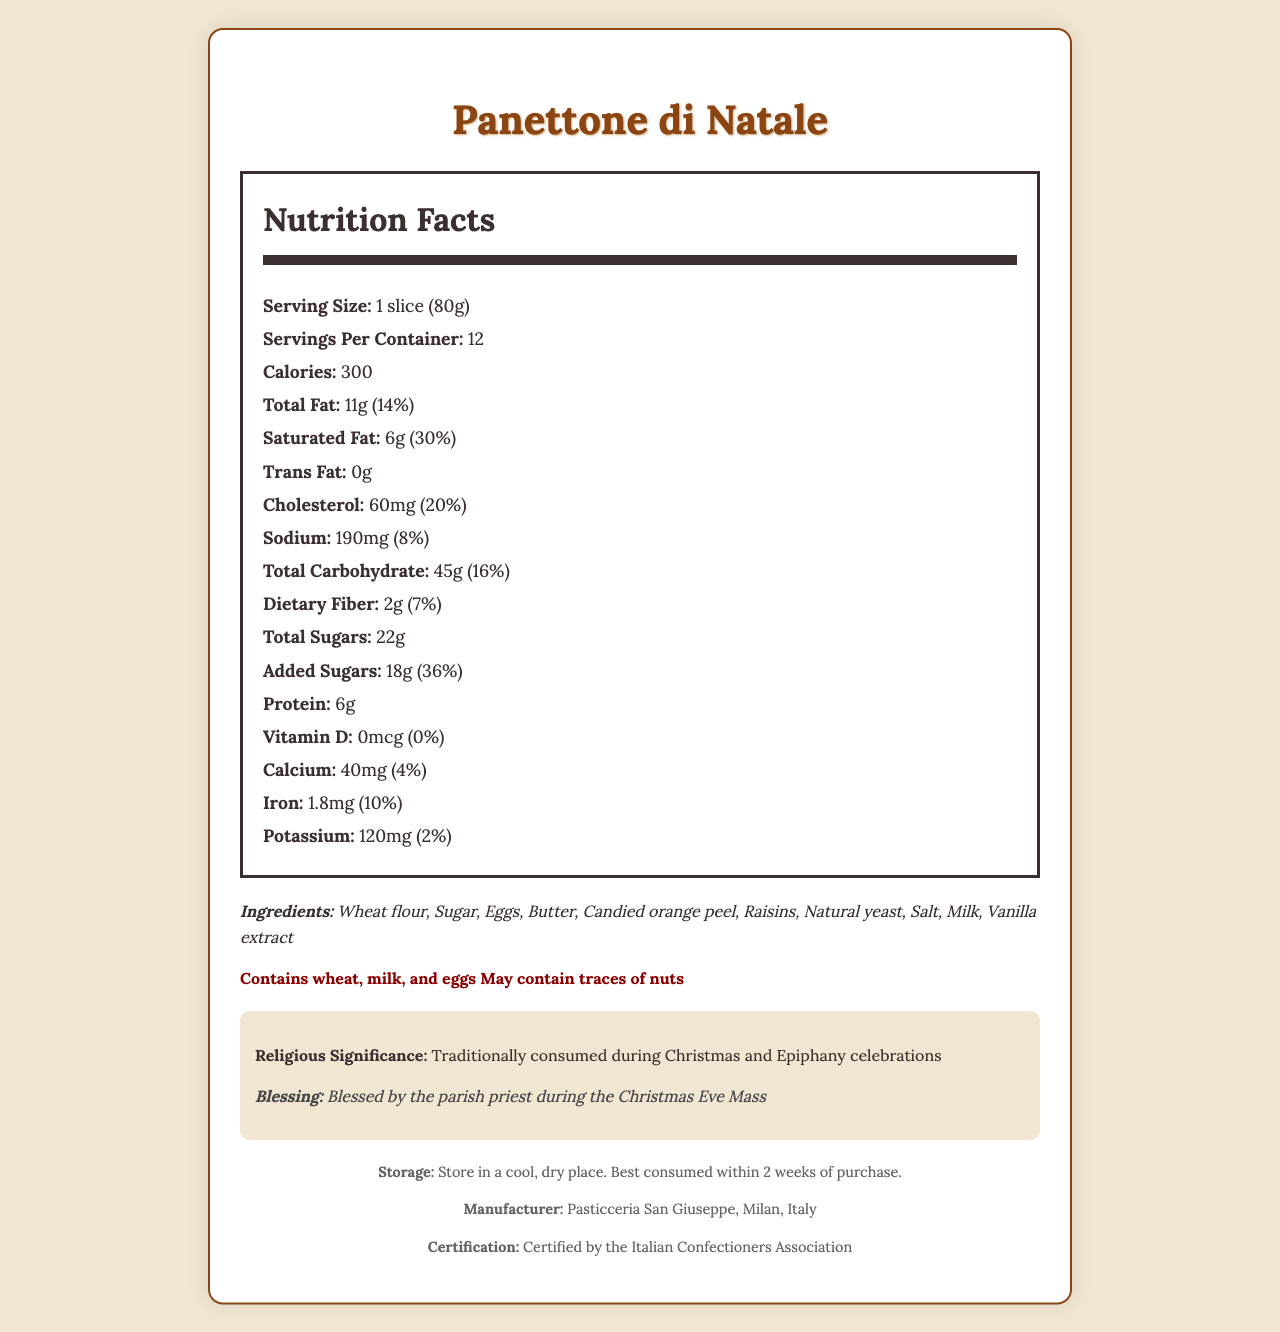what is the serving size? The serving size is listed at the beginning of the Nutrition Facts section: "1 slice (80g)".
Answer: 1 slice (80g) how many servings are there per container? The number of servings per container is provided directly below the serving size: "Servings Per Container: 12".
Answer: 12 how many calories are there per serving? The calories per serving are listed as "Calories: 300".
Answer: 300 what is the amount of total fat per serving? The amount of total fat per serving is mentioned as "Total Fat: 11g".
Answer: 11g what is the percentage of daily value for saturated fat per serving? The daily value percentage for saturated fat is given as "Saturated Fat: 6g (30%)".
Answer: 30% how much cholesterol is in one serving? The amount of cholesterol per serving is noted as "Cholesterol: 60mg (20%)".
Answer: 60mg what percentage of the daily value of dietary fiber does one serving provide? The daily value percentage for dietary fiber per serving is "Dietary Fiber: 2g (7%)".
Answer: 7% how many grams of added sugars are there in one serving? The amount of added sugars per serving is given as "Added Sugars: 18g (36%)".
Answer: 18g what is the main ingredient of Panettone di Natale? A. Eggs B. Butter C. Wheat flour D. Milk The first ingredient listed is "Wheat flour", indicating it's the main ingredient by quantity.
Answer: C. Wheat flour which of the following nutrients does not provide any daily value? A. Vitamin D B. Calcium C. Iron D. Potassium The daily value for Vitamin D is "0%" as mentioned in the document.
Answer: A. Vitamin D does the Panettone di Natale contain nuts? The allergens section mentions "May contain traces of nuts".
Answer: It may contain traces of nuts is the document only about the nutritional content of Panettone di Natale? The document includes not only nutritional content but also ingredients, allergens, religious significance, blessing, storage, manufacturer, and certification information.
Answer: No summarize the main information presented in the document. The document contains comprehensive information about Panettone di Natale, focusing on its nutritional content, ingredient list, allergens, religious context, manufacturer, and proper storage methods.
Answer: The document provides an extensive overview of Panettone di Natale, including its nutritional facts per 1 slice (80g), ingredients, allergens, religious significance, blessing by a parish priest during Christmas Eve Mass, storage instructions, manufacturer details, and certification by the Italian Confectioners Association. who is the target audience of this document? The document does not specify who the target audience is.
Answer: Cannot be determined who certifies the Panettone di Natale? The certification section states: "Certified by the Italian Confectioners Association".
Answer: The Italian Confectioners Association how should the Panettone di Natale be stored? The storage instructions provide this information clearly: "Store in a cool, dry place. Best consumed within 2 weeks of purchase".
Answer: Store in a cool, dry place. Best consumed within 2 weeks of purchase. how much protein is there in one serving? The protein content per serving is listed as "Protein: 6g".
Answer: 6g what is the religious significance of Panettone di Natale? The religious significance section states this: "Traditionally consumed during Christmas and Epiphany celebrations".
Answer: Traditionally consumed during Christmas and Epiphany celebrations which of the following is not an ingredient in Panettone di Natale? A. Vanilla extract B. Butter C. Almonds D. Milk Almonds are not listed under the ingredients section.
Answer: C. Almonds 